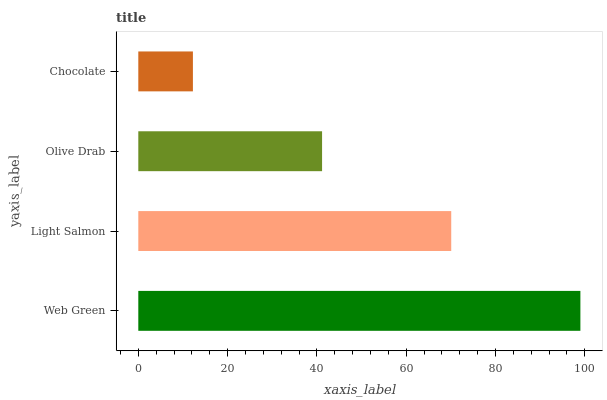Is Chocolate the minimum?
Answer yes or no. Yes. Is Web Green the maximum?
Answer yes or no. Yes. Is Light Salmon the minimum?
Answer yes or no. No. Is Light Salmon the maximum?
Answer yes or no. No. Is Web Green greater than Light Salmon?
Answer yes or no. Yes. Is Light Salmon less than Web Green?
Answer yes or no. Yes. Is Light Salmon greater than Web Green?
Answer yes or no. No. Is Web Green less than Light Salmon?
Answer yes or no. No. Is Light Salmon the high median?
Answer yes or no. Yes. Is Olive Drab the low median?
Answer yes or no. Yes. Is Olive Drab the high median?
Answer yes or no. No. Is Light Salmon the low median?
Answer yes or no. No. 